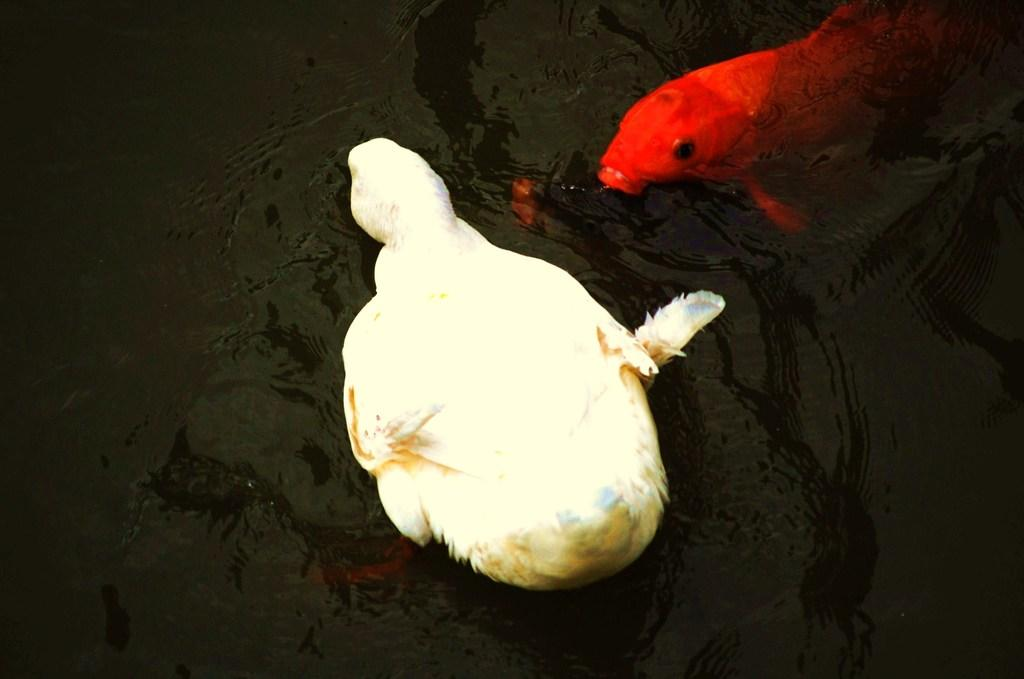What type of animal can be seen in the image? There is a bird in the image. Can you describe the bird's appearance? The bird is in cream and brown color. What other animal is present in the image? There is a fish in the image. How is the fish characterized? The fish is in red color. Where are the bird and the fish located in the image? The bird and the fish are in the water. What type of crayon is the bird using to draw in the image? There is no crayon present in the image, and the bird is not drawing. 